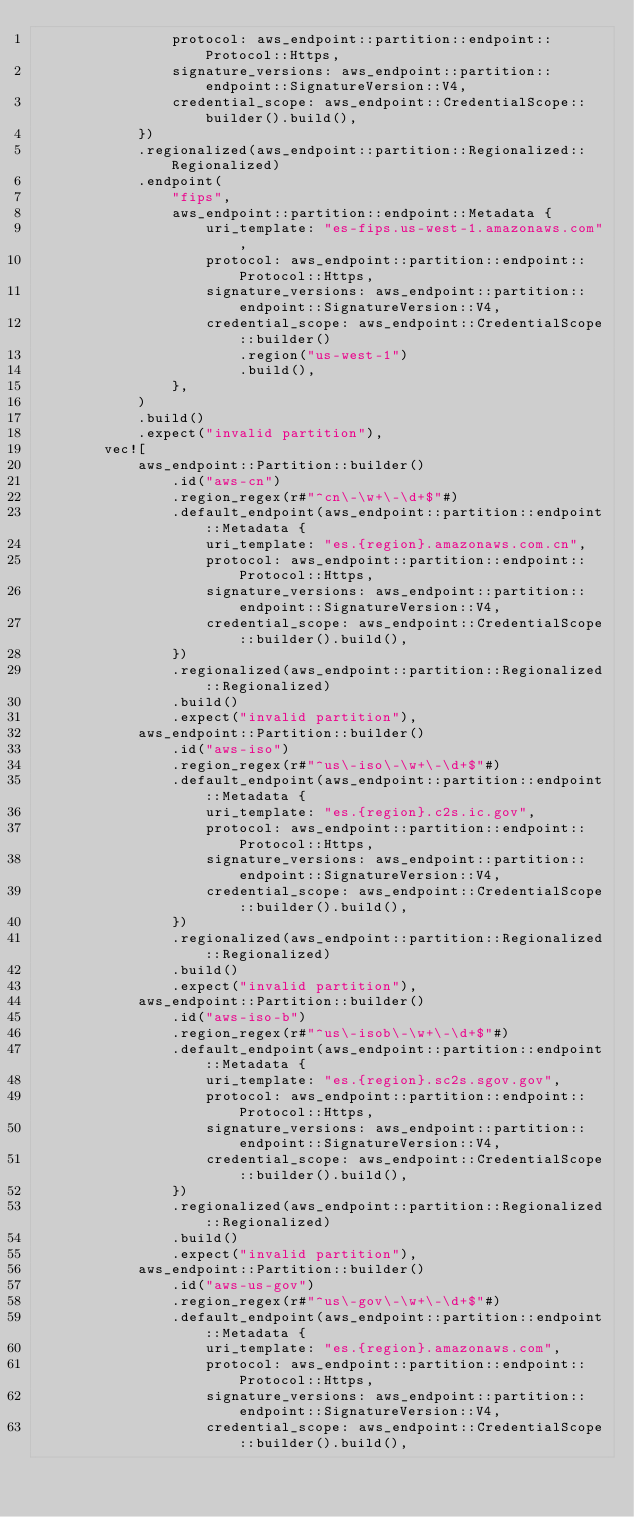<code> <loc_0><loc_0><loc_500><loc_500><_Rust_>                protocol: aws_endpoint::partition::endpoint::Protocol::Https,
                signature_versions: aws_endpoint::partition::endpoint::SignatureVersion::V4,
                credential_scope: aws_endpoint::CredentialScope::builder().build(),
            })
            .regionalized(aws_endpoint::partition::Regionalized::Regionalized)
            .endpoint(
                "fips",
                aws_endpoint::partition::endpoint::Metadata {
                    uri_template: "es-fips.us-west-1.amazonaws.com",
                    protocol: aws_endpoint::partition::endpoint::Protocol::Https,
                    signature_versions: aws_endpoint::partition::endpoint::SignatureVersion::V4,
                    credential_scope: aws_endpoint::CredentialScope::builder()
                        .region("us-west-1")
                        .build(),
                },
            )
            .build()
            .expect("invalid partition"),
        vec![
            aws_endpoint::Partition::builder()
                .id("aws-cn")
                .region_regex(r#"^cn\-\w+\-\d+$"#)
                .default_endpoint(aws_endpoint::partition::endpoint::Metadata {
                    uri_template: "es.{region}.amazonaws.com.cn",
                    protocol: aws_endpoint::partition::endpoint::Protocol::Https,
                    signature_versions: aws_endpoint::partition::endpoint::SignatureVersion::V4,
                    credential_scope: aws_endpoint::CredentialScope::builder().build(),
                })
                .regionalized(aws_endpoint::partition::Regionalized::Regionalized)
                .build()
                .expect("invalid partition"),
            aws_endpoint::Partition::builder()
                .id("aws-iso")
                .region_regex(r#"^us\-iso\-\w+\-\d+$"#)
                .default_endpoint(aws_endpoint::partition::endpoint::Metadata {
                    uri_template: "es.{region}.c2s.ic.gov",
                    protocol: aws_endpoint::partition::endpoint::Protocol::Https,
                    signature_versions: aws_endpoint::partition::endpoint::SignatureVersion::V4,
                    credential_scope: aws_endpoint::CredentialScope::builder().build(),
                })
                .regionalized(aws_endpoint::partition::Regionalized::Regionalized)
                .build()
                .expect("invalid partition"),
            aws_endpoint::Partition::builder()
                .id("aws-iso-b")
                .region_regex(r#"^us\-isob\-\w+\-\d+$"#)
                .default_endpoint(aws_endpoint::partition::endpoint::Metadata {
                    uri_template: "es.{region}.sc2s.sgov.gov",
                    protocol: aws_endpoint::partition::endpoint::Protocol::Https,
                    signature_versions: aws_endpoint::partition::endpoint::SignatureVersion::V4,
                    credential_scope: aws_endpoint::CredentialScope::builder().build(),
                })
                .regionalized(aws_endpoint::partition::Regionalized::Regionalized)
                .build()
                .expect("invalid partition"),
            aws_endpoint::Partition::builder()
                .id("aws-us-gov")
                .region_regex(r#"^us\-gov\-\w+\-\d+$"#)
                .default_endpoint(aws_endpoint::partition::endpoint::Metadata {
                    uri_template: "es.{region}.amazonaws.com",
                    protocol: aws_endpoint::partition::endpoint::Protocol::Https,
                    signature_versions: aws_endpoint::partition::endpoint::SignatureVersion::V4,
                    credential_scope: aws_endpoint::CredentialScope::builder().build(),</code> 